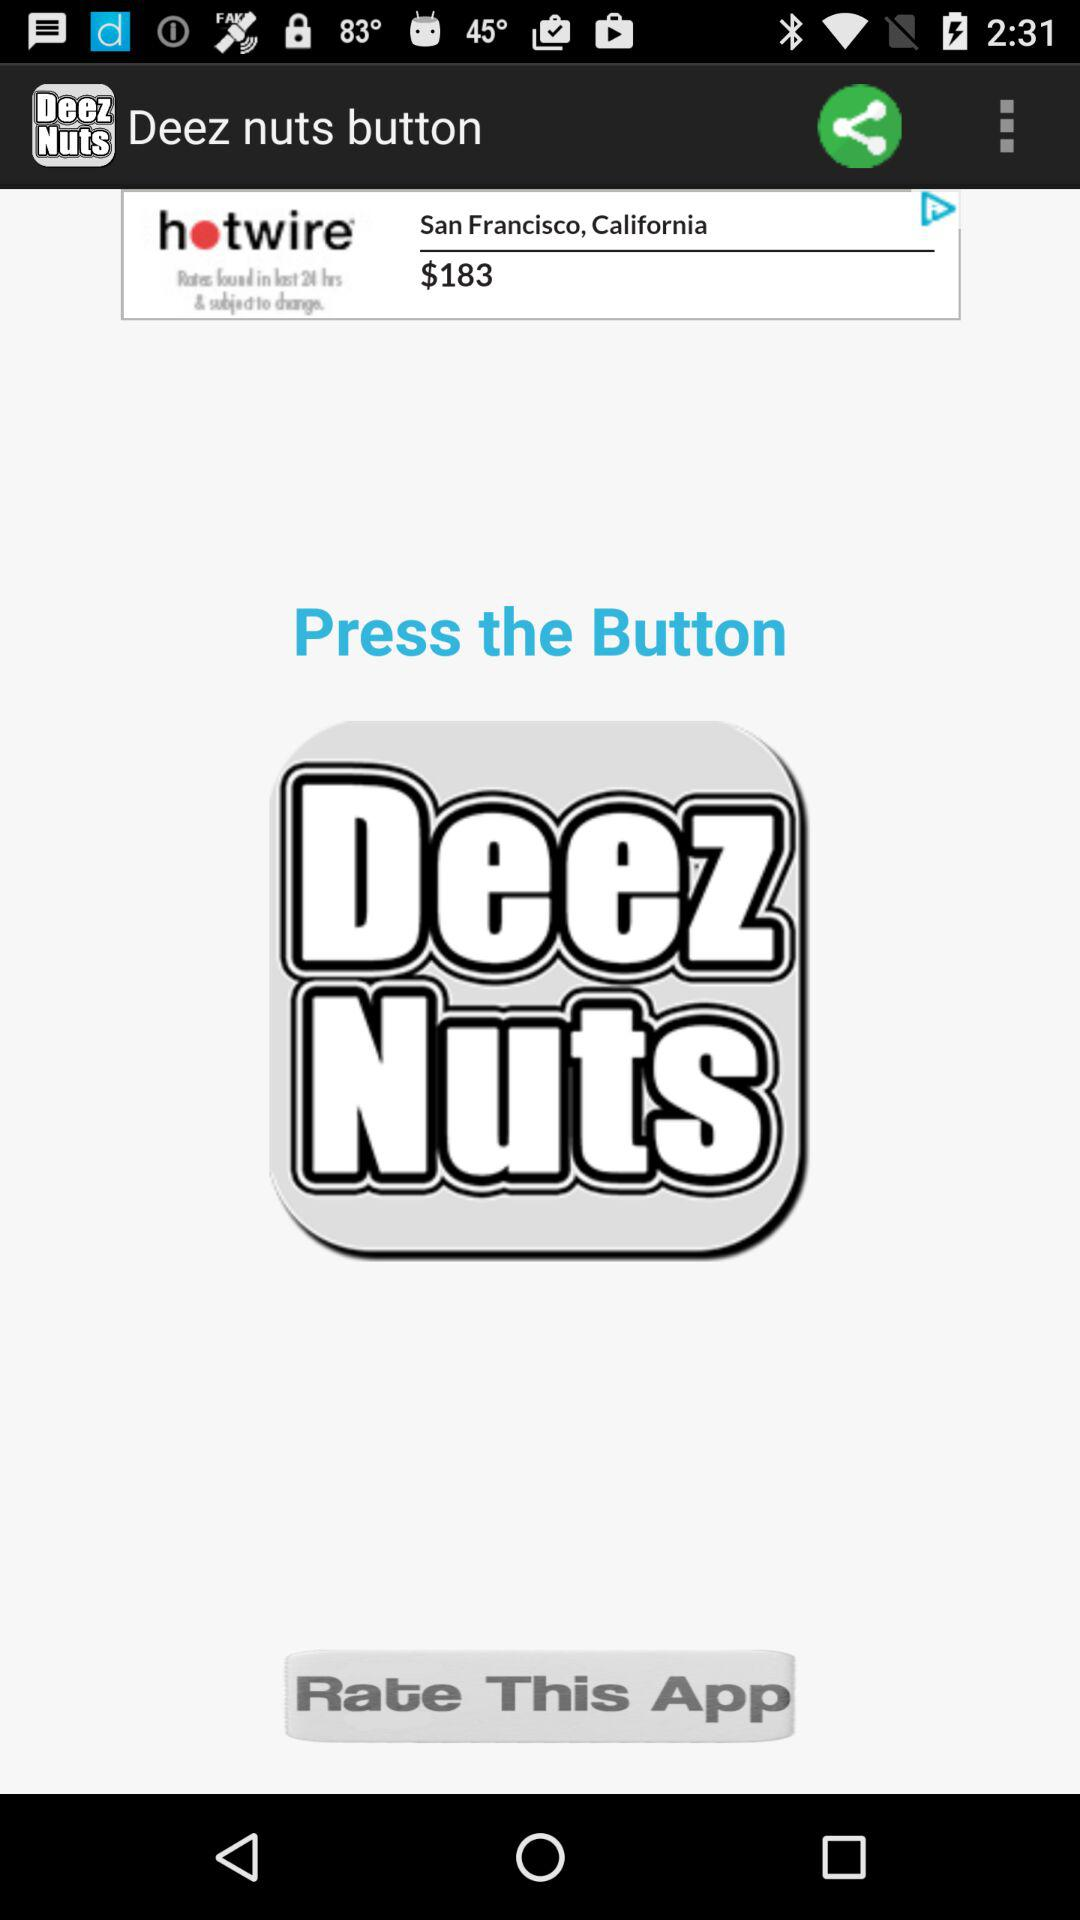What is the application name? The application name is "Deez nuts button". 